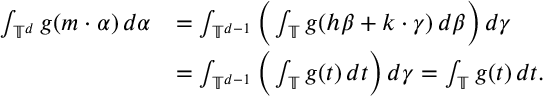<formula> <loc_0><loc_0><loc_500><loc_500>\begin{array} { r l } { \int _ { \mathbb { T } ^ { d } } g ( m \cdot \alpha ) \, d \alpha } & { = \int _ { \mathbb { T } ^ { d - 1 } } \left ( \int _ { \mathbb { T } } g ( h \beta + k \cdot \gamma ) \, d \beta \right ) \, d \gamma } \\ & { = \int _ { \mathbb { T } ^ { d - 1 } } \left ( \int _ { \mathbb { T } } g ( t ) \, d t \right ) \, d \gamma = \int _ { \mathbb { T } } g ( t ) \, d t . } \end{array}</formula> 